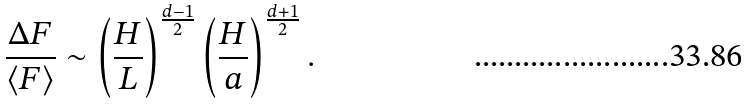Convert formula to latex. <formula><loc_0><loc_0><loc_500><loc_500>\frac { \Delta F } { \langle F \rangle } \sim \left ( \frac { H } { L } \right ) ^ { \frac { d - 1 } { 2 } } \left ( \frac { H } { a } \right ) ^ { \frac { d + 1 } { 2 } } .</formula> 